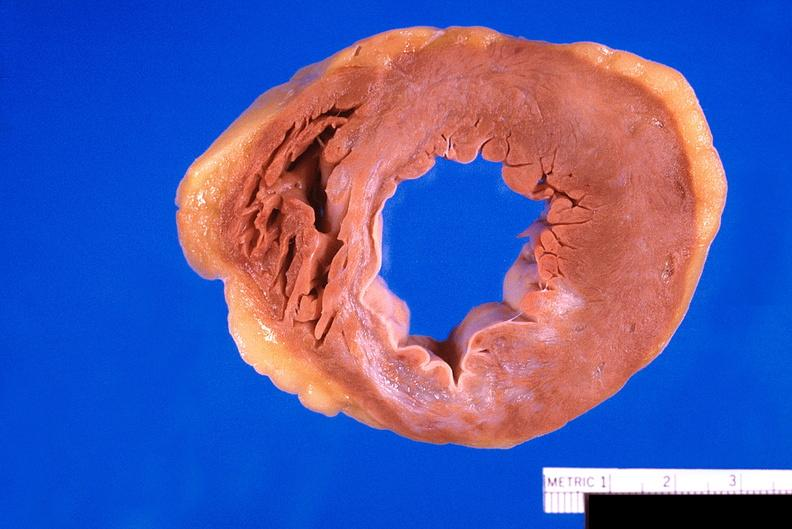how does this image show heart, old myocardial infarction?
Answer the question using a single word or phrase. With fibrosis 